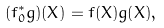<formula> <loc_0><loc_0><loc_500><loc_500>( f ^ { * } _ { 0 } g ) ( X ) = f ( X ) g ( X ) ,</formula> 